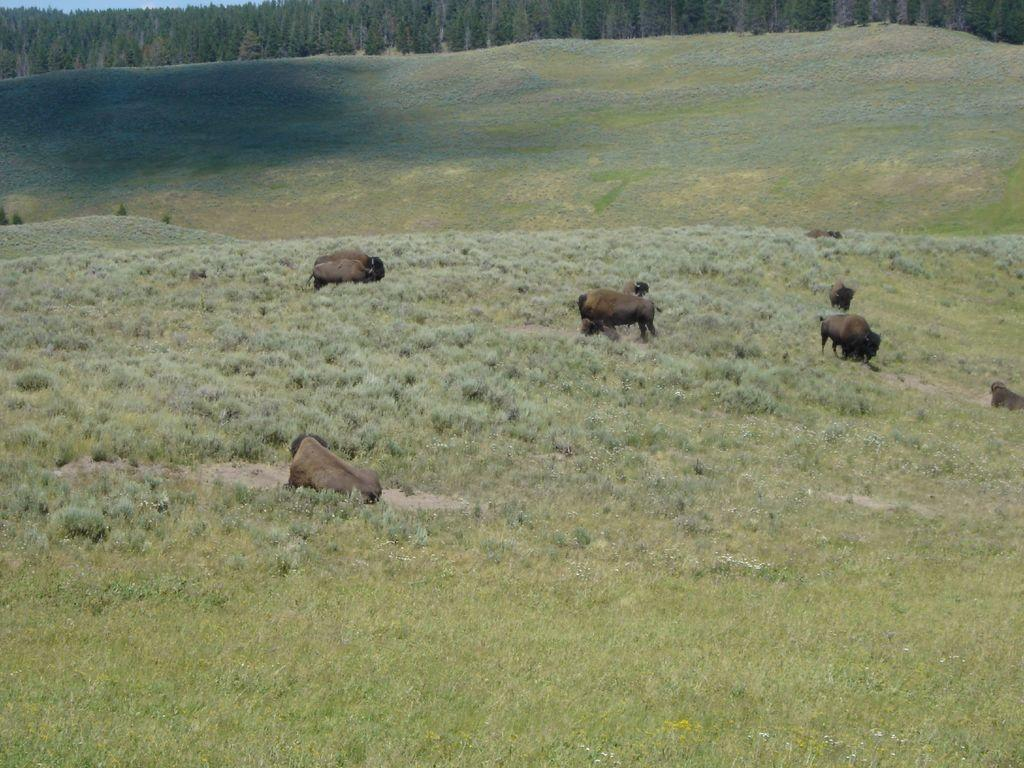What types of living organisms can be seen in the image? There are animals in the image. What are the animals doing in the image? Some of the animals are sitting, while others are standing. What is the color of the ground in the image? The ground in the image is green. What can be seen in the background of the image? There are trees in the background of the image. What type of hair can be seen on the minister in the image? There is no minister present in the image, and therefore no hair to observe. How many balloons are visible in the image? There are no balloons present in the image. 